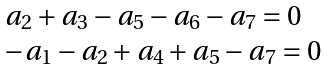Convert formula to latex. <formula><loc_0><loc_0><loc_500><loc_500>\begin{array} { l } a _ { 2 } + a _ { 3 } - a _ { 5 } - a _ { 6 } - a _ { 7 } = 0 \\ - a _ { 1 } - a _ { 2 } + a _ { 4 } + a _ { 5 } - a _ { 7 } = 0 \end{array}</formula> 